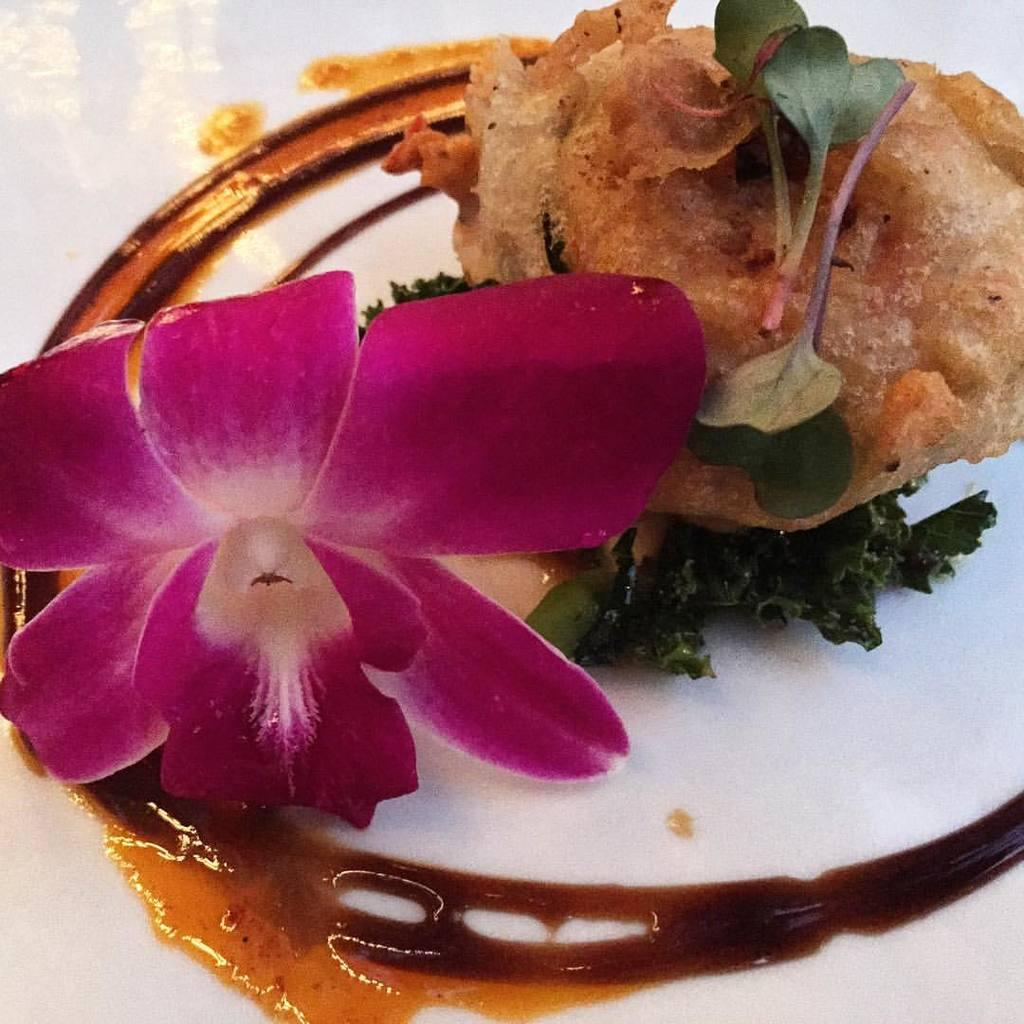What type of food item is visible in the image? There is a food item in the image, but the specific type cannot be determined from the provided facts. What other object is present in the image besides the food item? There is a flower in the image. What type of jar is visible in the image? There is no jar present in the image. What specific detail can be seen on the petals of the flower in the image? The provided facts do not include any details about the flower's petals, so we cannot answer this question definitively. 